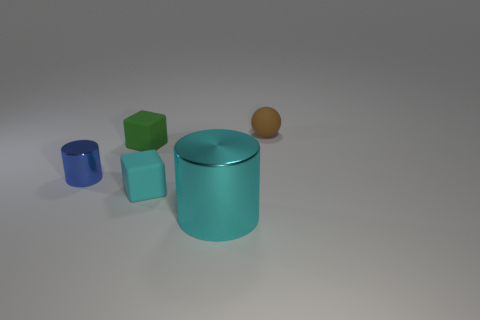Add 2 small green objects. How many objects exist? 7 Subtract all spheres. How many objects are left? 4 Add 5 yellow rubber spheres. How many yellow rubber spheres exist? 5 Subtract 0 brown blocks. How many objects are left? 5 Subtract all gray rubber things. Subtract all cyan cubes. How many objects are left? 4 Add 1 blue metallic things. How many blue metallic things are left? 2 